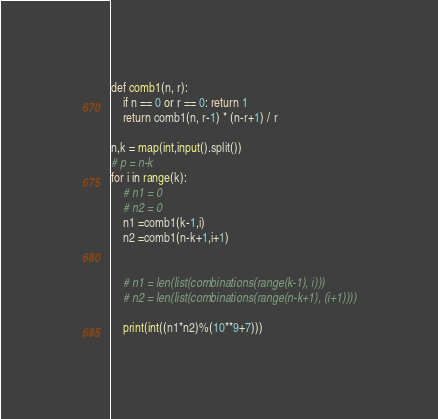Convert code to text. <code><loc_0><loc_0><loc_500><loc_500><_Python_>def comb1(n, r):
    if n == 0 or r == 0: return 1
    return comb1(n, r-1) * (n-r+1) / r 

n,k = map(int,input().split())
# p = n-k
for i in range(k):
	# n1 = 0
	# n2 = 0
	n1 =comb1(k-1,i)
	n2 =comb1(n-k+1,i+1)


	# n1 = len(list(combinations(range(k-1), i)))
	# n2 = len(list(combinations(range(n-k+1), (i+1))))

	print(int((n1*n2)%(10**9+7)))</code> 